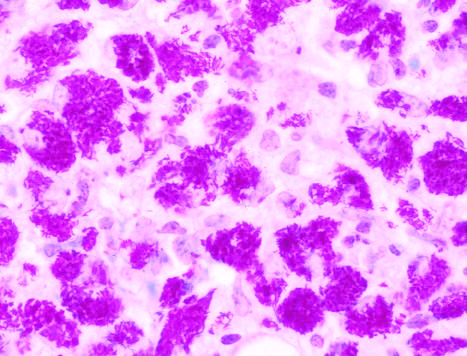re sheets of macrophages packed with mycobacteria seen in this specimen from an immunosuppressed patient?
Answer the question using a single word or phrase. Yes 